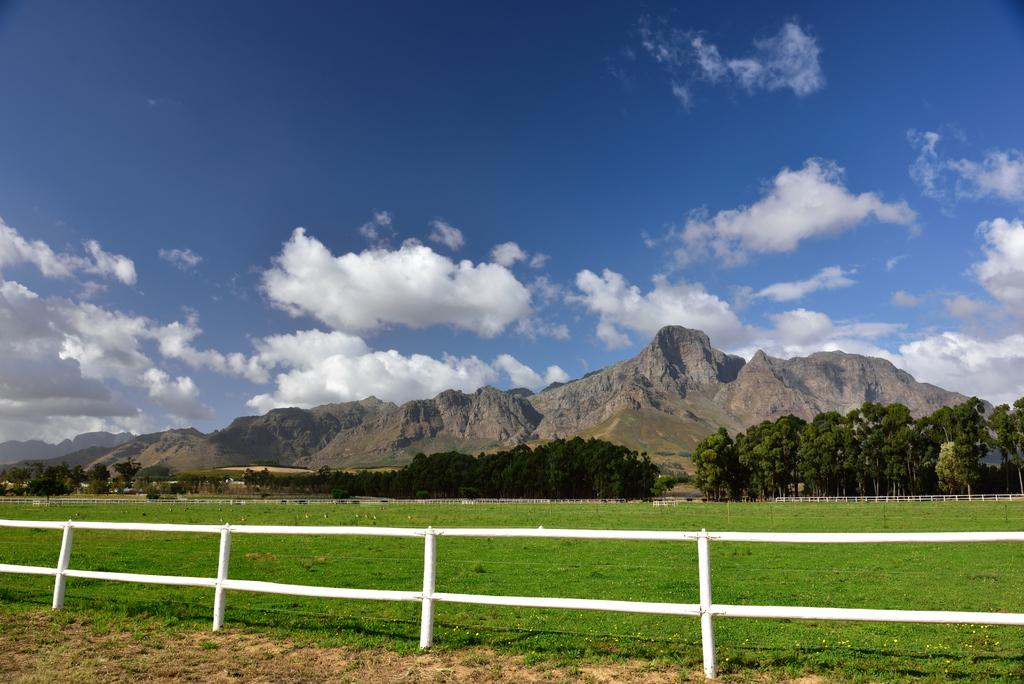What can be seen in the sky in the background of the image? There are clouds in the sky in the background of the image. What type of natural features are visible in the background of the image? There are hills visible in the background of the image. What type of vegetation is present in the image? There are trees in the image. What type of ground cover is present in the image? There is green grass in the image. What type of barrier is present in the image? There is a fence in the image. What type of clock is hanging from the tree in the image? There is no clock present in the image; it features clouds, hills, trees, green grass, and a fence. What type of riddle can be solved by observing the rail in the image? There is no rail present in the image; it features clouds, hills, trees, green grass, and a fence. 